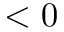<formula> <loc_0><loc_0><loc_500><loc_500>< 0</formula> 